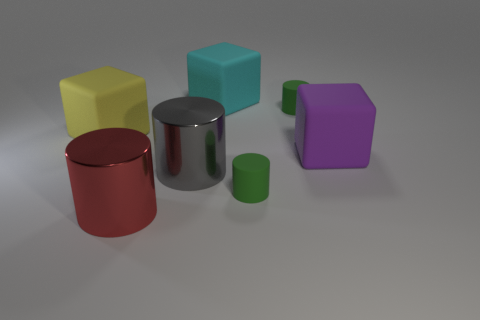Subtract all brown cylinders. Subtract all red cubes. How many cylinders are left? 4 Add 2 large gray balls. How many objects exist? 9 Subtract all cylinders. How many objects are left? 3 Subtract 0 brown spheres. How many objects are left? 7 Subtract all large red metal cylinders. Subtract all purple things. How many objects are left? 5 Add 1 large yellow matte things. How many large yellow matte things are left? 2 Add 6 cylinders. How many cylinders exist? 10 